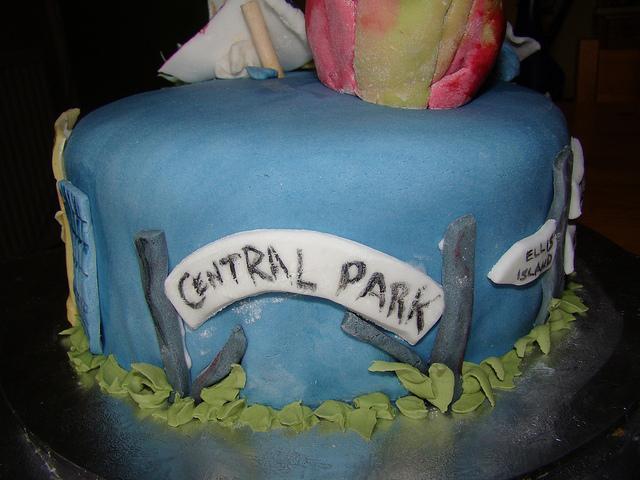How many cakes are in the photo?
Give a very brief answer. 1. 